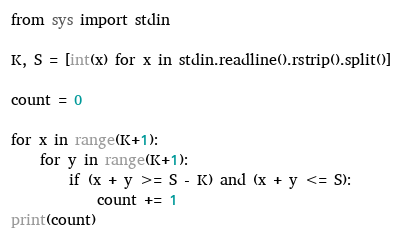<code> <loc_0><loc_0><loc_500><loc_500><_Python_>from sys import stdin

K, S = [int(x) for x in stdin.readline().rstrip().split()]

count = 0

for x in range(K+1):
    for y in range(K+1):
        if (x + y >= S - K) and (x + y <= S):
            count += 1
print(count)</code> 